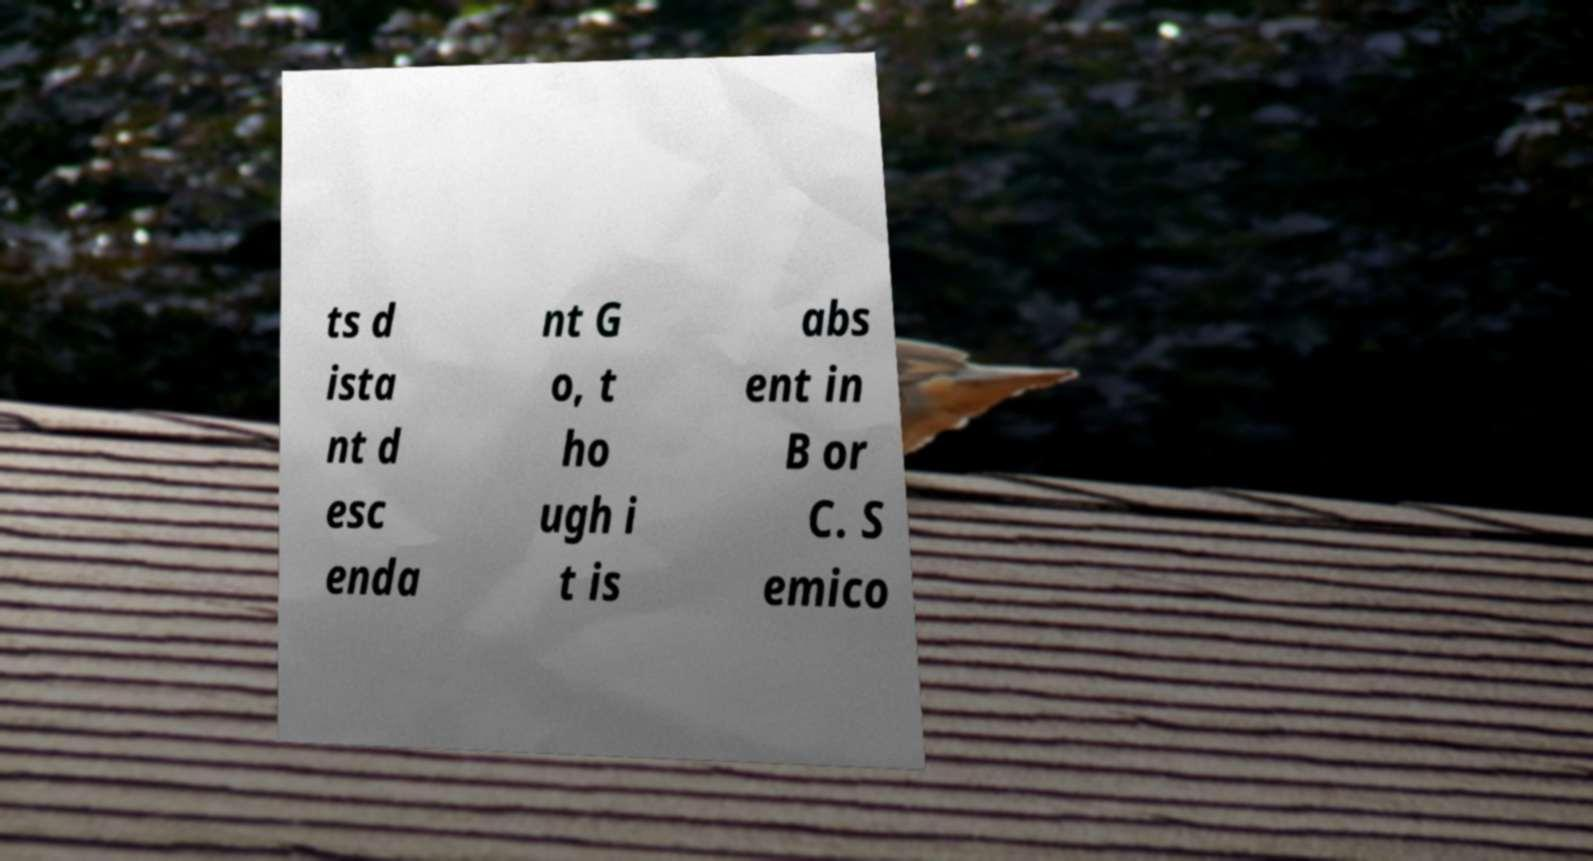For documentation purposes, I need the text within this image transcribed. Could you provide that? ts d ista nt d esc enda nt G o, t ho ugh i t is abs ent in B or C. S emico 